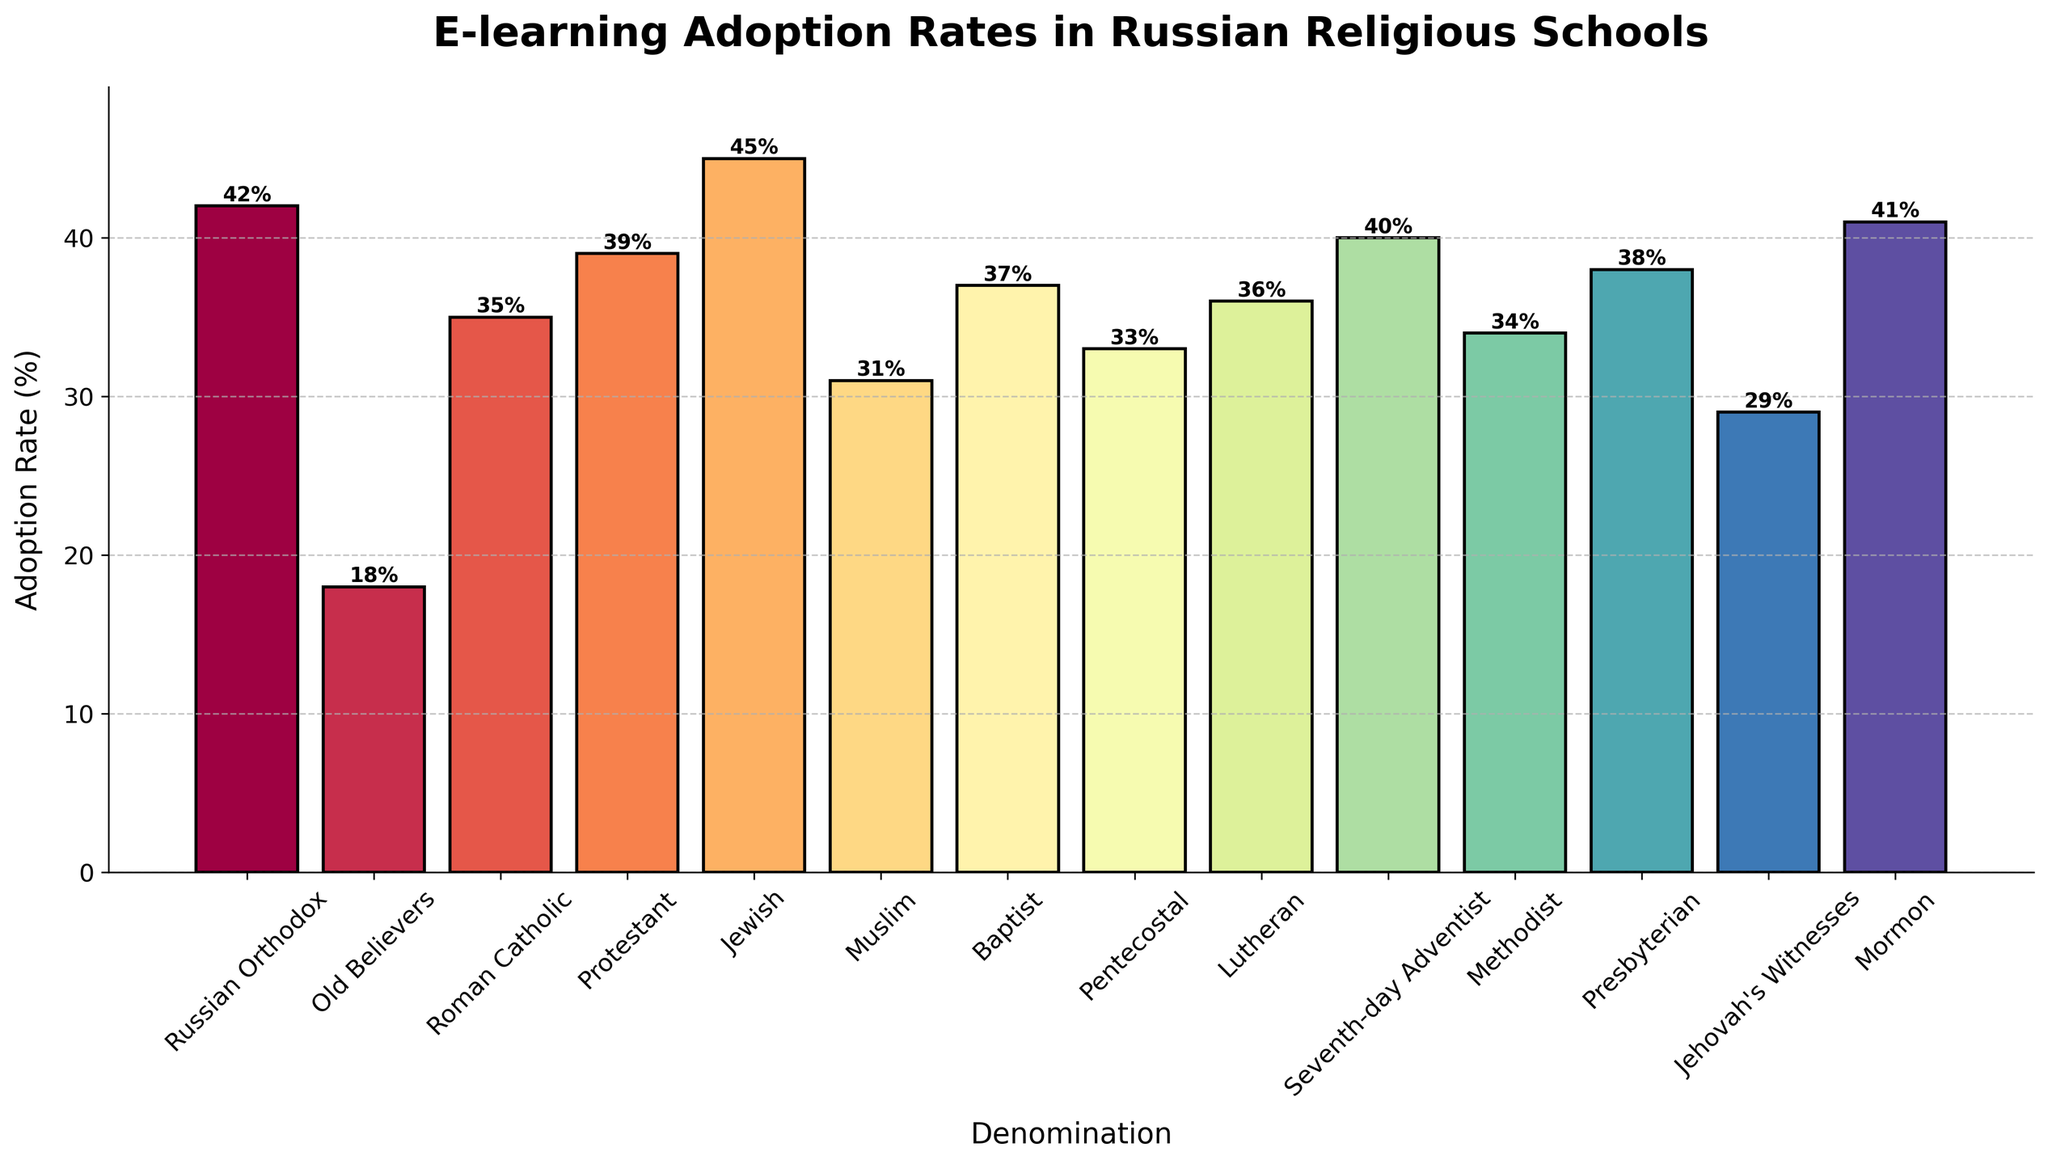What's the denomination with the highest adoption rate of e-learning tools? From the figure, identify the bar with the greatest height. The highest bar represents the denomination with the highest adoption rate. The Jewish denomination has the highest bar at 45%.
Answer: Jewish Which denomination has a higher e-learning adoption rate: Methodist or Pentecostal? Compare the height of the bars representing the Methodist and Pentecostal denominations. The Methodist bar reaches 34% while the Pentecostal bar reaches 33%. Since 34% is greater than 33%, the Methodist denomination has a higher adoption rate.
Answer: Methodist What's the difference in e-learning adoption rates between Russian Orthodox and Seventh-day Adventist denominations? Find the heights of the bars for Russian Orthodox and Seventh-day Adventist denominations, which are 42% and 40% respectively. Subtract 40% from 42% to get the difference: 42% - 40% = 2%.
Answer: 2% Which denominations have an adoption rate less than 30%? Identify bars that do not reach the 30% mark. The Old Believers adoption rate is 18%, and Jehovah's Witnesses adoption rate is 29%. Both are less than 30%.
Answer: Old Believers, Jehovah's Witnesses What's the average adoption rate across all listed denominations? Sum all the percentages from the given data and then divide by the number of denominations: (42+18+35+39+45+31+37+33+36+40+34+38+29+41) / 14. This results in an average adoption rate of 35.9%.
Answer: 35.9% Are there more denominations above or below the average adoption rate? Calculate the average adoption rate as 35.9%. Then count the number of denominations with adoption rates above and below this value. Above: (42, 45, 39, 37, 36, 40, 41); Below: (18, 35, 31, 33, 34, 29). There are 7 denominations above and 7 below the average, meaning they are equal.
Answer: Equal By how much does the adoption rate of the Baptist denomination exceed that of the Muslim denomination? Compare the bars for Baptist (37%) and Muslim (31%) denominations. Subtract 31% from 37% to find the difference: 37% - 31% = 6%.
Answer: 6% What's the adoption rate of the Roman Catholic denomination, and is it higher or lower than the overall average? The adoption rate for Roman Catholic is 35%. Compare this to the average adoption rate of 35.9%. Since 35% is less than 35.9%, it is lower.
Answer: 35%, lower Which denominations have e-learning adoption rates nearest to the median value of the data set? The median is the middle value of an ordered data set. Order the adoption rates: 18, 29, 31, 33, 34, 35, 36, 37, 38, 39, 40, 41, 42, 45. The median values are 36 and 37; thus, the denominations with adoption rates nearest to the median are Lutheran (36%) and Baptist (37%).
Answer: Lutheran, Baptist 